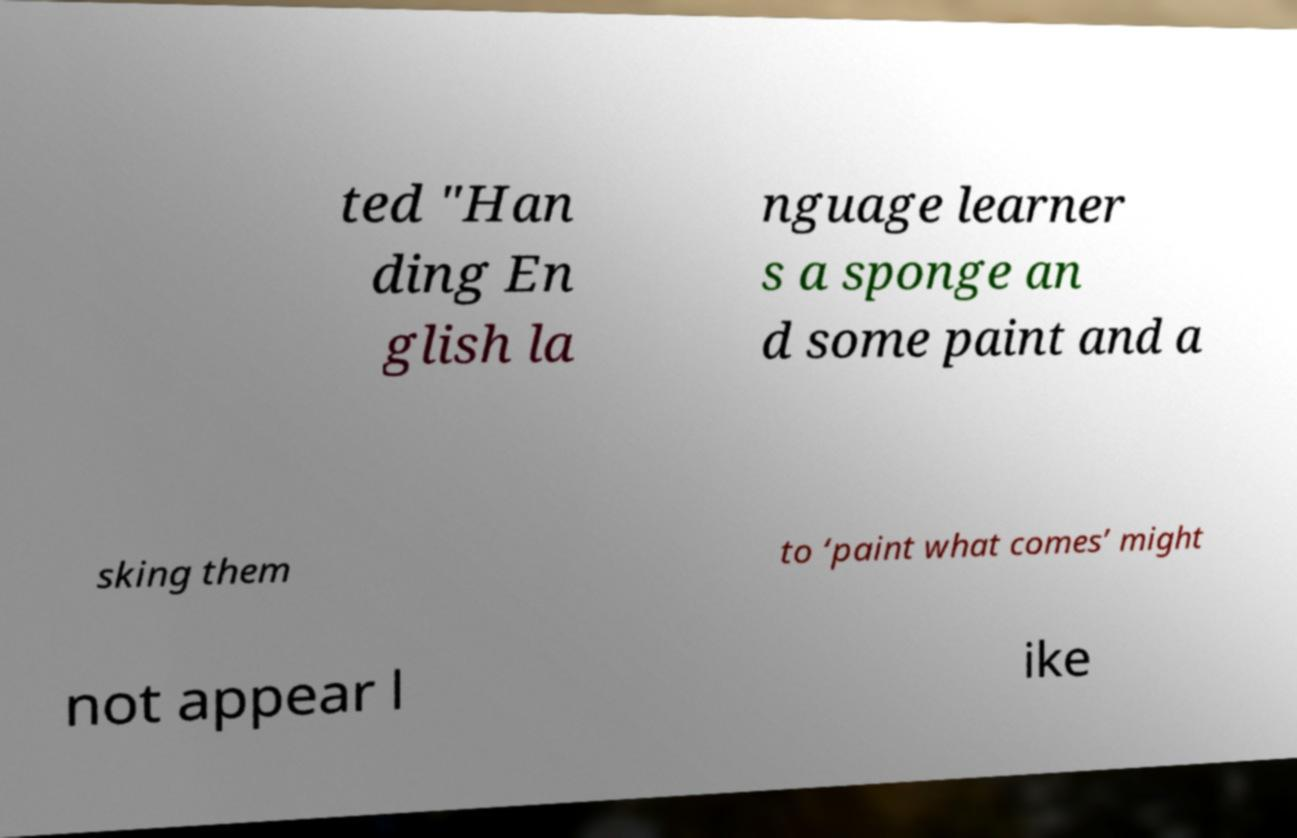I need the written content from this picture converted into text. Can you do that? ted "Han ding En glish la nguage learner s a sponge an d some paint and a sking them to ‘paint what comes’ might not appear l ike 